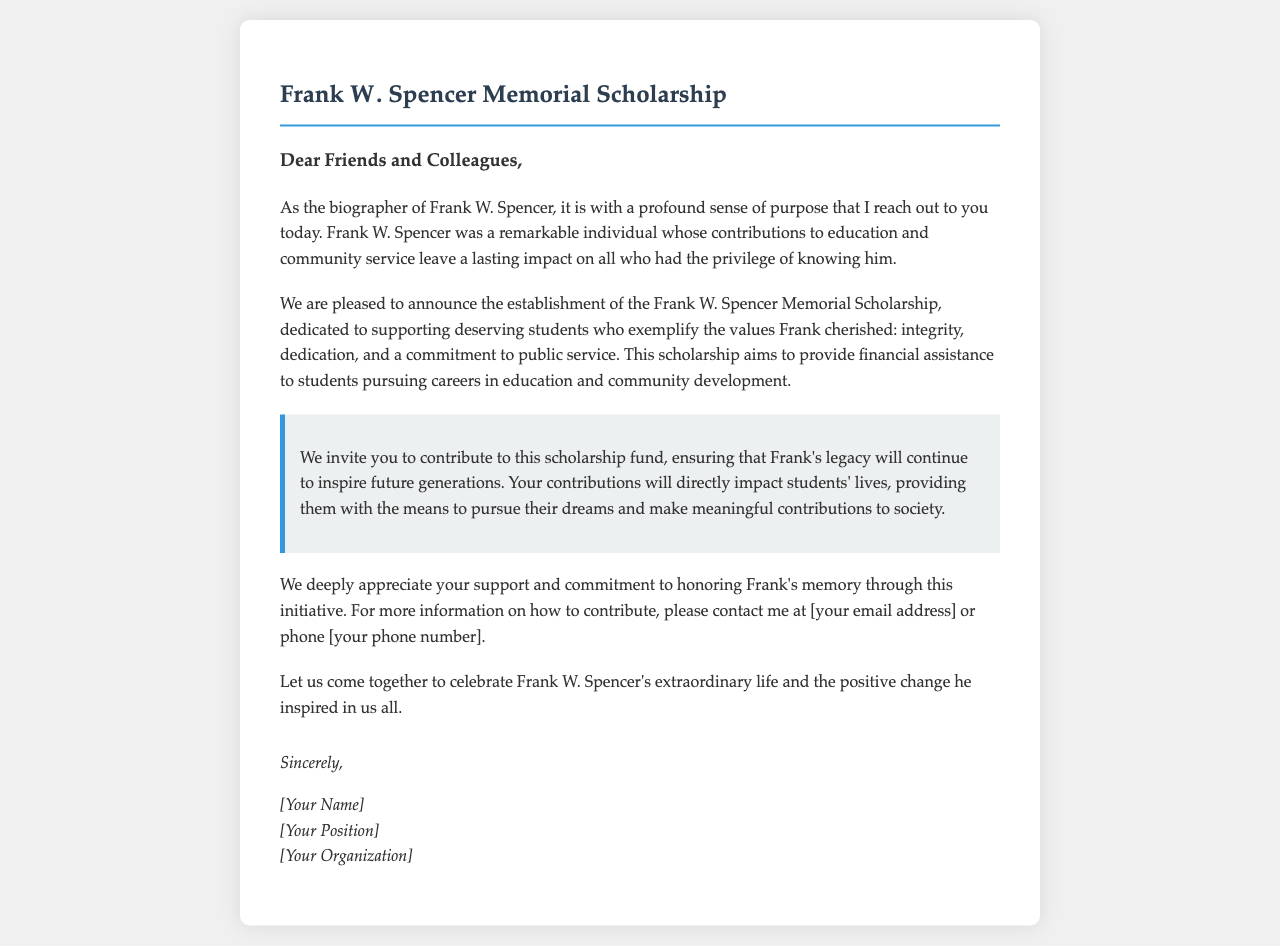What is the purpose of the Frank W. Spencer Memorial Scholarship? The purpose of the scholarship is to support deserving students who exemplify the values Frank cherished, focusing on education and community development.
Answer: To support deserving students Who is invited to contribute to the scholarship fund? The letter invites friends and colleagues to contribute to the scholarship fund in Frank W. Spencer's name.
Answer: Friends and colleagues What values does the scholarship aim to uphold? The scholarship aims to uphold the values of integrity, dedication, and a commitment to public service.
Answer: Integrity, dedication, and commitment to public service What type of support does the scholarship provide? The scholarship provides financial assistance to students pursuing careers in education and community development.
Answer: Financial assistance How should contributions be directed? Contributions can be directed by contacting the author of the letter via email or phone, as stated in the document.
Answer: Email or phone What is the tone of the letter? The tone of the letter is sincere and respectful, reflecting a commitment to honoring Frank's memory.
Answer: Sincere and respectful In what year is this letter likely written? The letter does not specify a particular year, but implies it is recent due to the contemporary context of establishing a scholarship in memory of Frank W. Spencer.
Answer: Recent What action does the letter encourage regarding Frank's legacy? The letter encourages coming together to celebrate Frank W. Spencer's extraordinary life and to contribute to his legacy through the scholarship.
Answer: Celebrate his life and contribute to his legacy 